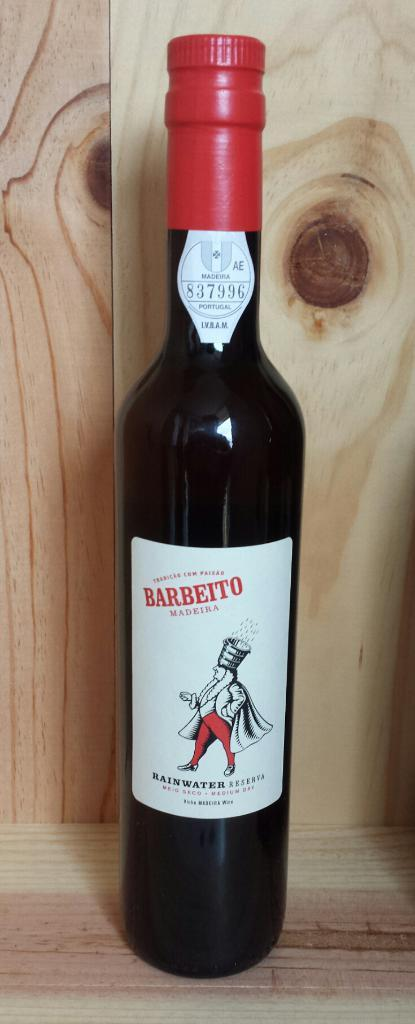<image>
Render a clear and concise summary of the photo. A bottle of rainwater is set on a wooden shelf. 